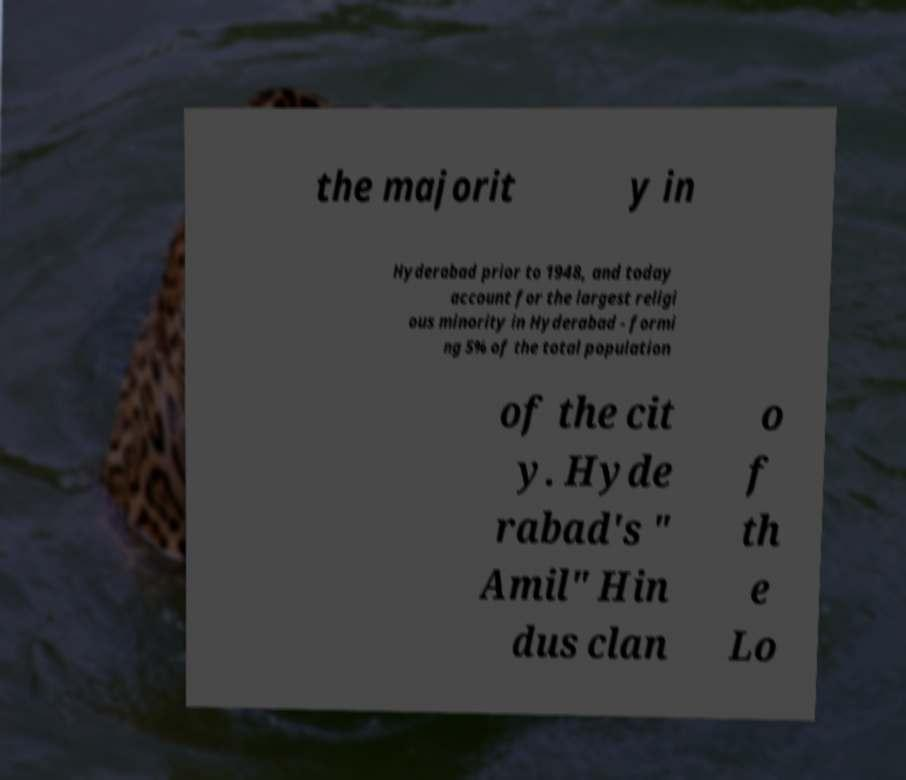There's text embedded in this image that I need extracted. Can you transcribe it verbatim? the majorit y in Hyderabad prior to 1948, and today account for the largest religi ous minority in Hyderabad - formi ng 5% of the total population of the cit y. Hyde rabad's " Amil" Hin dus clan o f th e Lo 